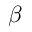Convert formula to latex. <formula><loc_0><loc_0><loc_500><loc_500>\beta</formula> 